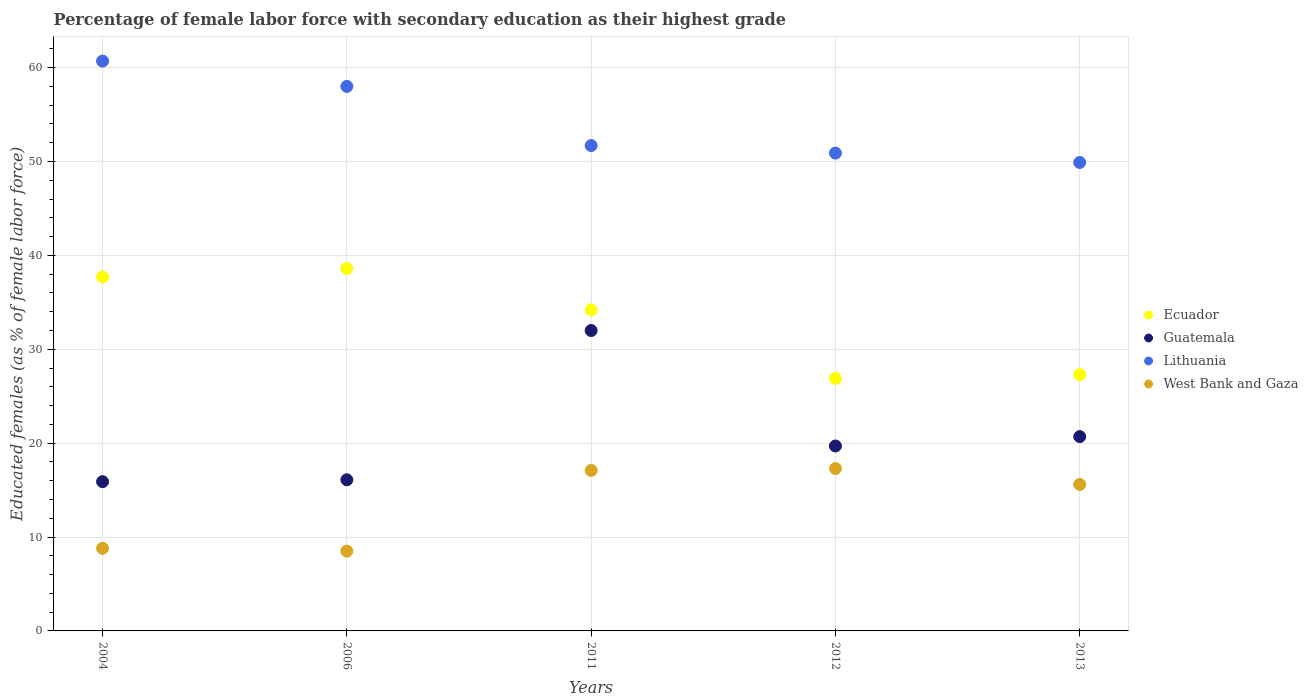How many different coloured dotlines are there?
Your answer should be very brief. 4. Is the number of dotlines equal to the number of legend labels?
Your answer should be very brief. Yes. Across all years, what is the maximum percentage of female labor force with secondary education in Lithuania?
Your answer should be compact. 60.7. Across all years, what is the minimum percentage of female labor force with secondary education in Ecuador?
Make the answer very short. 26.9. In which year was the percentage of female labor force with secondary education in Lithuania minimum?
Provide a short and direct response. 2013. What is the total percentage of female labor force with secondary education in Ecuador in the graph?
Ensure brevity in your answer.  164.7. What is the difference between the percentage of female labor force with secondary education in West Bank and Gaza in 2012 and that in 2013?
Provide a succinct answer. 1.7. What is the difference between the percentage of female labor force with secondary education in Guatemala in 2006 and the percentage of female labor force with secondary education in West Bank and Gaza in 2013?
Provide a succinct answer. 0.5. What is the average percentage of female labor force with secondary education in Guatemala per year?
Give a very brief answer. 20.88. In the year 2013, what is the difference between the percentage of female labor force with secondary education in Lithuania and percentage of female labor force with secondary education in Ecuador?
Make the answer very short. 22.6. What is the ratio of the percentage of female labor force with secondary education in Lithuania in 2004 to that in 2006?
Give a very brief answer. 1.05. Is the percentage of female labor force with secondary education in Lithuania in 2011 less than that in 2013?
Offer a very short reply. No. Is the difference between the percentage of female labor force with secondary education in Lithuania in 2006 and 2011 greater than the difference between the percentage of female labor force with secondary education in Ecuador in 2006 and 2011?
Give a very brief answer. Yes. What is the difference between the highest and the second highest percentage of female labor force with secondary education in Ecuador?
Offer a terse response. 0.9. What is the difference between the highest and the lowest percentage of female labor force with secondary education in Guatemala?
Provide a succinct answer. 16.1. Is it the case that in every year, the sum of the percentage of female labor force with secondary education in Ecuador and percentage of female labor force with secondary education in Lithuania  is greater than the sum of percentage of female labor force with secondary education in Guatemala and percentage of female labor force with secondary education in West Bank and Gaza?
Your answer should be compact. Yes. How many dotlines are there?
Give a very brief answer. 4. How many years are there in the graph?
Give a very brief answer. 5. What is the difference between two consecutive major ticks on the Y-axis?
Your answer should be compact. 10. Does the graph contain any zero values?
Your answer should be compact. No. Does the graph contain grids?
Your answer should be very brief. Yes. What is the title of the graph?
Provide a succinct answer. Percentage of female labor force with secondary education as their highest grade. Does "Guinea" appear as one of the legend labels in the graph?
Ensure brevity in your answer.  No. What is the label or title of the Y-axis?
Your response must be concise. Educated females (as % of female labor force). What is the Educated females (as % of female labor force) in Ecuador in 2004?
Offer a terse response. 37.7. What is the Educated females (as % of female labor force) of Guatemala in 2004?
Provide a succinct answer. 15.9. What is the Educated females (as % of female labor force) of Lithuania in 2004?
Keep it short and to the point. 60.7. What is the Educated females (as % of female labor force) of West Bank and Gaza in 2004?
Offer a very short reply. 8.8. What is the Educated females (as % of female labor force) of Ecuador in 2006?
Your response must be concise. 38.6. What is the Educated females (as % of female labor force) of Guatemala in 2006?
Your answer should be compact. 16.1. What is the Educated females (as % of female labor force) of Ecuador in 2011?
Provide a succinct answer. 34.2. What is the Educated females (as % of female labor force) of Lithuania in 2011?
Your answer should be compact. 51.7. What is the Educated females (as % of female labor force) in West Bank and Gaza in 2011?
Ensure brevity in your answer.  17.1. What is the Educated females (as % of female labor force) in Ecuador in 2012?
Provide a short and direct response. 26.9. What is the Educated females (as % of female labor force) in Guatemala in 2012?
Your answer should be compact. 19.7. What is the Educated females (as % of female labor force) in Lithuania in 2012?
Keep it short and to the point. 50.9. What is the Educated females (as % of female labor force) of West Bank and Gaza in 2012?
Your response must be concise. 17.3. What is the Educated females (as % of female labor force) of Ecuador in 2013?
Your answer should be compact. 27.3. What is the Educated females (as % of female labor force) of Guatemala in 2013?
Your answer should be very brief. 20.7. What is the Educated females (as % of female labor force) in Lithuania in 2013?
Your response must be concise. 49.9. What is the Educated females (as % of female labor force) in West Bank and Gaza in 2013?
Make the answer very short. 15.6. Across all years, what is the maximum Educated females (as % of female labor force) in Ecuador?
Your answer should be compact. 38.6. Across all years, what is the maximum Educated females (as % of female labor force) in Guatemala?
Provide a succinct answer. 32. Across all years, what is the maximum Educated females (as % of female labor force) of Lithuania?
Ensure brevity in your answer.  60.7. Across all years, what is the maximum Educated females (as % of female labor force) of West Bank and Gaza?
Give a very brief answer. 17.3. Across all years, what is the minimum Educated females (as % of female labor force) in Ecuador?
Offer a terse response. 26.9. Across all years, what is the minimum Educated females (as % of female labor force) of Guatemala?
Your answer should be very brief. 15.9. Across all years, what is the minimum Educated females (as % of female labor force) of Lithuania?
Provide a succinct answer. 49.9. What is the total Educated females (as % of female labor force) of Ecuador in the graph?
Give a very brief answer. 164.7. What is the total Educated females (as % of female labor force) in Guatemala in the graph?
Keep it short and to the point. 104.4. What is the total Educated females (as % of female labor force) in Lithuania in the graph?
Offer a very short reply. 271.2. What is the total Educated females (as % of female labor force) of West Bank and Gaza in the graph?
Ensure brevity in your answer.  67.3. What is the difference between the Educated females (as % of female labor force) of Lithuania in 2004 and that in 2006?
Your answer should be very brief. 2.7. What is the difference between the Educated females (as % of female labor force) in Guatemala in 2004 and that in 2011?
Your answer should be compact. -16.1. What is the difference between the Educated females (as % of female labor force) in Lithuania in 2004 and that in 2011?
Ensure brevity in your answer.  9. What is the difference between the Educated females (as % of female labor force) of West Bank and Gaza in 2004 and that in 2011?
Keep it short and to the point. -8.3. What is the difference between the Educated females (as % of female labor force) in Ecuador in 2004 and that in 2012?
Offer a terse response. 10.8. What is the difference between the Educated females (as % of female labor force) of Lithuania in 2004 and that in 2012?
Offer a very short reply. 9.8. What is the difference between the Educated females (as % of female labor force) of West Bank and Gaza in 2004 and that in 2012?
Make the answer very short. -8.5. What is the difference between the Educated females (as % of female labor force) of Lithuania in 2004 and that in 2013?
Provide a succinct answer. 10.8. What is the difference between the Educated females (as % of female labor force) of Guatemala in 2006 and that in 2011?
Your answer should be compact. -15.9. What is the difference between the Educated females (as % of female labor force) of Lithuania in 2006 and that in 2011?
Your response must be concise. 6.3. What is the difference between the Educated females (as % of female labor force) of Lithuania in 2006 and that in 2012?
Offer a terse response. 7.1. What is the difference between the Educated females (as % of female labor force) in West Bank and Gaza in 2006 and that in 2012?
Ensure brevity in your answer.  -8.8. What is the difference between the Educated females (as % of female labor force) in Ecuador in 2006 and that in 2013?
Offer a terse response. 11.3. What is the difference between the Educated females (as % of female labor force) in Guatemala in 2006 and that in 2013?
Your response must be concise. -4.6. What is the difference between the Educated females (as % of female labor force) of Ecuador in 2011 and that in 2012?
Your response must be concise. 7.3. What is the difference between the Educated females (as % of female labor force) in Guatemala in 2011 and that in 2012?
Keep it short and to the point. 12.3. What is the difference between the Educated females (as % of female labor force) of West Bank and Gaza in 2011 and that in 2012?
Give a very brief answer. -0.2. What is the difference between the Educated females (as % of female labor force) in Guatemala in 2011 and that in 2013?
Provide a succinct answer. 11.3. What is the difference between the Educated females (as % of female labor force) in West Bank and Gaza in 2011 and that in 2013?
Provide a succinct answer. 1.5. What is the difference between the Educated females (as % of female labor force) of Ecuador in 2012 and that in 2013?
Provide a short and direct response. -0.4. What is the difference between the Educated females (as % of female labor force) in Guatemala in 2012 and that in 2013?
Offer a very short reply. -1. What is the difference between the Educated females (as % of female labor force) of Lithuania in 2012 and that in 2013?
Offer a terse response. 1. What is the difference between the Educated females (as % of female labor force) of Ecuador in 2004 and the Educated females (as % of female labor force) of Guatemala in 2006?
Ensure brevity in your answer.  21.6. What is the difference between the Educated females (as % of female labor force) in Ecuador in 2004 and the Educated females (as % of female labor force) in Lithuania in 2006?
Provide a short and direct response. -20.3. What is the difference between the Educated females (as % of female labor force) of Ecuador in 2004 and the Educated females (as % of female labor force) of West Bank and Gaza in 2006?
Provide a short and direct response. 29.2. What is the difference between the Educated females (as % of female labor force) of Guatemala in 2004 and the Educated females (as % of female labor force) of Lithuania in 2006?
Your answer should be very brief. -42.1. What is the difference between the Educated females (as % of female labor force) of Lithuania in 2004 and the Educated females (as % of female labor force) of West Bank and Gaza in 2006?
Offer a terse response. 52.2. What is the difference between the Educated females (as % of female labor force) of Ecuador in 2004 and the Educated females (as % of female labor force) of Guatemala in 2011?
Ensure brevity in your answer.  5.7. What is the difference between the Educated females (as % of female labor force) of Ecuador in 2004 and the Educated females (as % of female labor force) of West Bank and Gaza in 2011?
Keep it short and to the point. 20.6. What is the difference between the Educated females (as % of female labor force) of Guatemala in 2004 and the Educated females (as % of female labor force) of Lithuania in 2011?
Make the answer very short. -35.8. What is the difference between the Educated females (as % of female labor force) of Lithuania in 2004 and the Educated females (as % of female labor force) of West Bank and Gaza in 2011?
Offer a very short reply. 43.6. What is the difference between the Educated females (as % of female labor force) in Ecuador in 2004 and the Educated females (as % of female labor force) in West Bank and Gaza in 2012?
Ensure brevity in your answer.  20.4. What is the difference between the Educated females (as % of female labor force) in Guatemala in 2004 and the Educated females (as % of female labor force) in Lithuania in 2012?
Provide a succinct answer. -35. What is the difference between the Educated females (as % of female labor force) in Lithuania in 2004 and the Educated females (as % of female labor force) in West Bank and Gaza in 2012?
Provide a short and direct response. 43.4. What is the difference between the Educated females (as % of female labor force) in Ecuador in 2004 and the Educated females (as % of female labor force) in Guatemala in 2013?
Ensure brevity in your answer.  17. What is the difference between the Educated females (as % of female labor force) of Ecuador in 2004 and the Educated females (as % of female labor force) of Lithuania in 2013?
Give a very brief answer. -12.2. What is the difference between the Educated females (as % of female labor force) of Ecuador in 2004 and the Educated females (as % of female labor force) of West Bank and Gaza in 2013?
Provide a succinct answer. 22.1. What is the difference between the Educated females (as % of female labor force) of Guatemala in 2004 and the Educated females (as % of female labor force) of Lithuania in 2013?
Your answer should be compact. -34. What is the difference between the Educated females (as % of female labor force) of Guatemala in 2004 and the Educated females (as % of female labor force) of West Bank and Gaza in 2013?
Your answer should be compact. 0.3. What is the difference between the Educated females (as % of female labor force) in Lithuania in 2004 and the Educated females (as % of female labor force) in West Bank and Gaza in 2013?
Your response must be concise. 45.1. What is the difference between the Educated females (as % of female labor force) of Ecuador in 2006 and the Educated females (as % of female labor force) of Guatemala in 2011?
Your answer should be compact. 6.6. What is the difference between the Educated females (as % of female labor force) in Ecuador in 2006 and the Educated females (as % of female labor force) in Lithuania in 2011?
Ensure brevity in your answer.  -13.1. What is the difference between the Educated females (as % of female labor force) of Ecuador in 2006 and the Educated females (as % of female labor force) of West Bank and Gaza in 2011?
Offer a very short reply. 21.5. What is the difference between the Educated females (as % of female labor force) of Guatemala in 2006 and the Educated females (as % of female labor force) of Lithuania in 2011?
Your answer should be compact. -35.6. What is the difference between the Educated females (as % of female labor force) of Guatemala in 2006 and the Educated females (as % of female labor force) of West Bank and Gaza in 2011?
Offer a very short reply. -1. What is the difference between the Educated females (as % of female labor force) of Lithuania in 2006 and the Educated females (as % of female labor force) of West Bank and Gaza in 2011?
Provide a succinct answer. 40.9. What is the difference between the Educated females (as % of female labor force) in Ecuador in 2006 and the Educated females (as % of female labor force) in Guatemala in 2012?
Make the answer very short. 18.9. What is the difference between the Educated females (as % of female labor force) in Ecuador in 2006 and the Educated females (as % of female labor force) in Lithuania in 2012?
Your response must be concise. -12.3. What is the difference between the Educated females (as % of female labor force) of Ecuador in 2006 and the Educated females (as % of female labor force) of West Bank and Gaza in 2012?
Make the answer very short. 21.3. What is the difference between the Educated females (as % of female labor force) in Guatemala in 2006 and the Educated females (as % of female labor force) in Lithuania in 2012?
Provide a short and direct response. -34.8. What is the difference between the Educated females (as % of female labor force) of Lithuania in 2006 and the Educated females (as % of female labor force) of West Bank and Gaza in 2012?
Provide a succinct answer. 40.7. What is the difference between the Educated females (as % of female labor force) of Ecuador in 2006 and the Educated females (as % of female labor force) of Guatemala in 2013?
Your answer should be very brief. 17.9. What is the difference between the Educated females (as % of female labor force) of Ecuador in 2006 and the Educated females (as % of female labor force) of Lithuania in 2013?
Make the answer very short. -11.3. What is the difference between the Educated females (as % of female labor force) in Ecuador in 2006 and the Educated females (as % of female labor force) in West Bank and Gaza in 2013?
Offer a very short reply. 23. What is the difference between the Educated females (as % of female labor force) of Guatemala in 2006 and the Educated females (as % of female labor force) of Lithuania in 2013?
Give a very brief answer. -33.8. What is the difference between the Educated females (as % of female labor force) in Lithuania in 2006 and the Educated females (as % of female labor force) in West Bank and Gaza in 2013?
Provide a short and direct response. 42.4. What is the difference between the Educated females (as % of female labor force) of Ecuador in 2011 and the Educated females (as % of female labor force) of Lithuania in 2012?
Your answer should be very brief. -16.7. What is the difference between the Educated females (as % of female labor force) in Ecuador in 2011 and the Educated females (as % of female labor force) in West Bank and Gaza in 2012?
Provide a short and direct response. 16.9. What is the difference between the Educated females (as % of female labor force) in Guatemala in 2011 and the Educated females (as % of female labor force) in Lithuania in 2012?
Your response must be concise. -18.9. What is the difference between the Educated females (as % of female labor force) in Lithuania in 2011 and the Educated females (as % of female labor force) in West Bank and Gaza in 2012?
Give a very brief answer. 34.4. What is the difference between the Educated females (as % of female labor force) in Ecuador in 2011 and the Educated females (as % of female labor force) in Guatemala in 2013?
Offer a very short reply. 13.5. What is the difference between the Educated females (as % of female labor force) of Ecuador in 2011 and the Educated females (as % of female labor force) of Lithuania in 2013?
Your answer should be very brief. -15.7. What is the difference between the Educated females (as % of female labor force) of Ecuador in 2011 and the Educated females (as % of female labor force) of West Bank and Gaza in 2013?
Provide a short and direct response. 18.6. What is the difference between the Educated females (as % of female labor force) of Guatemala in 2011 and the Educated females (as % of female labor force) of Lithuania in 2013?
Your answer should be very brief. -17.9. What is the difference between the Educated females (as % of female labor force) in Lithuania in 2011 and the Educated females (as % of female labor force) in West Bank and Gaza in 2013?
Make the answer very short. 36.1. What is the difference between the Educated females (as % of female labor force) of Ecuador in 2012 and the Educated females (as % of female labor force) of West Bank and Gaza in 2013?
Ensure brevity in your answer.  11.3. What is the difference between the Educated females (as % of female labor force) of Guatemala in 2012 and the Educated females (as % of female labor force) of Lithuania in 2013?
Ensure brevity in your answer.  -30.2. What is the difference between the Educated females (as % of female labor force) in Guatemala in 2012 and the Educated females (as % of female labor force) in West Bank and Gaza in 2013?
Your response must be concise. 4.1. What is the difference between the Educated females (as % of female labor force) in Lithuania in 2012 and the Educated females (as % of female labor force) in West Bank and Gaza in 2013?
Your answer should be very brief. 35.3. What is the average Educated females (as % of female labor force) of Ecuador per year?
Provide a short and direct response. 32.94. What is the average Educated females (as % of female labor force) in Guatemala per year?
Your answer should be compact. 20.88. What is the average Educated females (as % of female labor force) in Lithuania per year?
Give a very brief answer. 54.24. What is the average Educated females (as % of female labor force) of West Bank and Gaza per year?
Offer a terse response. 13.46. In the year 2004, what is the difference between the Educated females (as % of female labor force) of Ecuador and Educated females (as % of female labor force) of Guatemala?
Offer a very short reply. 21.8. In the year 2004, what is the difference between the Educated females (as % of female labor force) in Ecuador and Educated females (as % of female labor force) in West Bank and Gaza?
Make the answer very short. 28.9. In the year 2004, what is the difference between the Educated females (as % of female labor force) in Guatemala and Educated females (as % of female labor force) in Lithuania?
Make the answer very short. -44.8. In the year 2004, what is the difference between the Educated females (as % of female labor force) of Guatemala and Educated females (as % of female labor force) of West Bank and Gaza?
Offer a terse response. 7.1. In the year 2004, what is the difference between the Educated females (as % of female labor force) in Lithuania and Educated females (as % of female labor force) in West Bank and Gaza?
Your answer should be compact. 51.9. In the year 2006, what is the difference between the Educated females (as % of female labor force) of Ecuador and Educated females (as % of female labor force) of Guatemala?
Make the answer very short. 22.5. In the year 2006, what is the difference between the Educated females (as % of female labor force) of Ecuador and Educated females (as % of female labor force) of Lithuania?
Make the answer very short. -19.4. In the year 2006, what is the difference between the Educated females (as % of female labor force) of Ecuador and Educated females (as % of female labor force) of West Bank and Gaza?
Your answer should be very brief. 30.1. In the year 2006, what is the difference between the Educated females (as % of female labor force) in Guatemala and Educated females (as % of female labor force) in Lithuania?
Offer a terse response. -41.9. In the year 2006, what is the difference between the Educated females (as % of female labor force) in Guatemala and Educated females (as % of female labor force) in West Bank and Gaza?
Offer a very short reply. 7.6. In the year 2006, what is the difference between the Educated females (as % of female labor force) in Lithuania and Educated females (as % of female labor force) in West Bank and Gaza?
Make the answer very short. 49.5. In the year 2011, what is the difference between the Educated females (as % of female labor force) of Ecuador and Educated females (as % of female labor force) of Lithuania?
Offer a terse response. -17.5. In the year 2011, what is the difference between the Educated females (as % of female labor force) of Ecuador and Educated females (as % of female labor force) of West Bank and Gaza?
Provide a short and direct response. 17.1. In the year 2011, what is the difference between the Educated females (as % of female labor force) of Guatemala and Educated females (as % of female labor force) of Lithuania?
Provide a short and direct response. -19.7. In the year 2011, what is the difference between the Educated females (as % of female labor force) of Lithuania and Educated females (as % of female labor force) of West Bank and Gaza?
Keep it short and to the point. 34.6. In the year 2012, what is the difference between the Educated females (as % of female labor force) of Ecuador and Educated females (as % of female labor force) of Lithuania?
Your answer should be compact. -24. In the year 2012, what is the difference between the Educated females (as % of female labor force) in Ecuador and Educated females (as % of female labor force) in West Bank and Gaza?
Give a very brief answer. 9.6. In the year 2012, what is the difference between the Educated females (as % of female labor force) in Guatemala and Educated females (as % of female labor force) in Lithuania?
Your response must be concise. -31.2. In the year 2012, what is the difference between the Educated females (as % of female labor force) of Lithuania and Educated females (as % of female labor force) of West Bank and Gaza?
Ensure brevity in your answer.  33.6. In the year 2013, what is the difference between the Educated females (as % of female labor force) in Ecuador and Educated females (as % of female labor force) in Lithuania?
Your response must be concise. -22.6. In the year 2013, what is the difference between the Educated females (as % of female labor force) of Ecuador and Educated females (as % of female labor force) of West Bank and Gaza?
Make the answer very short. 11.7. In the year 2013, what is the difference between the Educated females (as % of female labor force) of Guatemala and Educated females (as % of female labor force) of Lithuania?
Your answer should be compact. -29.2. In the year 2013, what is the difference between the Educated females (as % of female labor force) in Guatemala and Educated females (as % of female labor force) in West Bank and Gaza?
Keep it short and to the point. 5.1. In the year 2013, what is the difference between the Educated females (as % of female labor force) in Lithuania and Educated females (as % of female labor force) in West Bank and Gaza?
Offer a terse response. 34.3. What is the ratio of the Educated females (as % of female labor force) in Ecuador in 2004 to that in 2006?
Give a very brief answer. 0.98. What is the ratio of the Educated females (as % of female labor force) of Guatemala in 2004 to that in 2006?
Offer a very short reply. 0.99. What is the ratio of the Educated females (as % of female labor force) in Lithuania in 2004 to that in 2006?
Keep it short and to the point. 1.05. What is the ratio of the Educated females (as % of female labor force) in West Bank and Gaza in 2004 to that in 2006?
Keep it short and to the point. 1.04. What is the ratio of the Educated females (as % of female labor force) of Ecuador in 2004 to that in 2011?
Make the answer very short. 1.1. What is the ratio of the Educated females (as % of female labor force) in Guatemala in 2004 to that in 2011?
Your response must be concise. 0.5. What is the ratio of the Educated females (as % of female labor force) of Lithuania in 2004 to that in 2011?
Ensure brevity in your answer.  1.17. What is the ratio of the Educated females (as % of female labor force) in West Bank and Gaza in 2004 to that in 2011?
Make the answer very short. 0.51. What is the ratio of the Educated females (as % of female labor force) in Ecuador in 2004 to that in 2012?
Give a very brief answer. 1.4. What is the ratio of the Educated females (as % of female labor force) in Guatemala in 2004 to that in 2012?
Offer a terse response. 0.81. What is the ratio of the Educated females (as % of female labor force) in Lithuania in 2004 to that in 2012?
Provide a succinct answer. 1.19. What is the ratio of the Educated females (as % of female labor force) of West Bank and Gaza in 2004 to that in 2012?
Keep it short and to the point. 0.51. What is the ratio of the Educated females (as % of female labor force) of Ecuador in 2004 to that in 2013?
Your answer should be very brief. 1.38. What is the ratio of the Educated females (as % of female labor force) in Guatemala in 2004 to that in 2013?
Offer a very short reply. 0.77. What is the ratio of the Educated females (as % of female labor force) of Lithuania in 2004 to that in 2013?
Make the answer very short. 1.22. What is the ratio of the Educated females (as % of female labor force) of West Bank and Gaza in 2004 to that in 2013?
Give a very brief answer. 0.56. What is the ratio of the Educated females (as % of female labor force) of Ecuador in 2006 to that in 2011?
Offer a terse response. 1.13. What is the ratio of the Educated females (as % of female labor force) of Guatemala in 2006 to that in 2011?
Make the answer very short. 0.5. What is the ratio of the Educated females (as % of female labor force) of Lithuania in 2006 to that in 2011?
Your answer should be very brief. 1.12. What is the ratio of the Educated females (as % of female labor force) in West Bank and Gaza in 2006 to that in 2011?
Ensure brevity in your answer.  0.5. What is the ratio of the Educated females (as % of female labor force) in Ecuador in 2006 to that in 2012?
Provide a short and direct response. 1.43. What is the ratio of the Educated females (as % of female labor force) of Guatemala in 2006 to that in 2012?
Offer a very short reply. 0.82. What is the ratio of the Educated females (as % of female labor force) in Lithuania in 2006 to that in 2012?
Provide a succinct answer. 1.14. What is the ratio of the Educated females (as % of female labor force) of West Bank and Gaza in 2006 to that in 2012?
Make the answer very short. 0.49. What is the ratio of the Educated females (as % of female labor force) of Ecuador in 2006 to that in 2013?
Ensure brevity in your answer.  1.41. What is the ratio of the Educated females (as % of female labor force) in Lithuania in 2006 to that in 2013?
Provide a succinct answer. 1.16. What is the ratio of the Educated females (as % of female labor force) in West Bank and Gaza in 2006 to that in 2013?
Make the answer very short. 0.54. What is the ratio of the Educated females (as % of female labor force) in Ecuador in 2011 to that in 2012?
Provide a succinct answer. 1.27. What is the ratio of the Educated females (as % of female labor force) in Guatemala in 2011 to that in 2012?
Provide a short and direct response. 1.62. What is the ratio of the Educated females (as % of female labor force) of Lithuania in 2011 to that in 2012?
Provide a short and direct response. 1.02. What is the ratio of the Educated females (as % of female labor force) of West Bank and Gaza in 2011 to that in 2012?
Provide a short and direct response. 0.99. What is the ratio of the Educated females (as % of female labor force) of Ecuador in 2011 to that in 2013?
Give a very brief answer. 1.25. What is the ratio of the Educated females (as % of female labor force) in Guatemala in 2011 to that in 2013?
Your answer should be very brief. 1.55. What is the ratio of the Educated females (as % of female labor force) in Lithuania in 2011 to that in 2013?
Your answer should be compact. 1.04. What is the ratio of the Educated females (as % of female labor force) of West Bank and Gaza in 2011 to that in 2013?
Keep it short and to the point. 1.1. What is the ratio of the Educated females (as % of female labor force) of Ecuador in 2012 to that in 2013?
Your answer should be compact. 0.99. What is the ratio of the Educated females (as % of female labor force) in Guatemala in 2012 to that in 2013?
Your answer should be compact. 0.95. What is the ratio of the Educated females (as % of female labor force) in West Bank and Gaza in 2012 to that in 2013?
Offer a terse response. 1.11. What is the difference between the highest and the lowest Educated females (as % of female labor force) of Ecuador?
Provide a short and direct response. 11.7. What is the difference between the highest and the lowest Educated females (as % of female labor force) in West Bank and Gaza?
Offer a terse response. 8.8. 